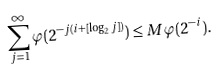<formula> <loc_0><loc_0><loc_500><loc_500>\sum _ { j = 1 } ^ { \infty } \varphi ( 2 ^ { - j ( i + [ \log _ { 2 } j ] ) } ) \leq M \varphi ( 2 ^ { - i } ) .</formula> 